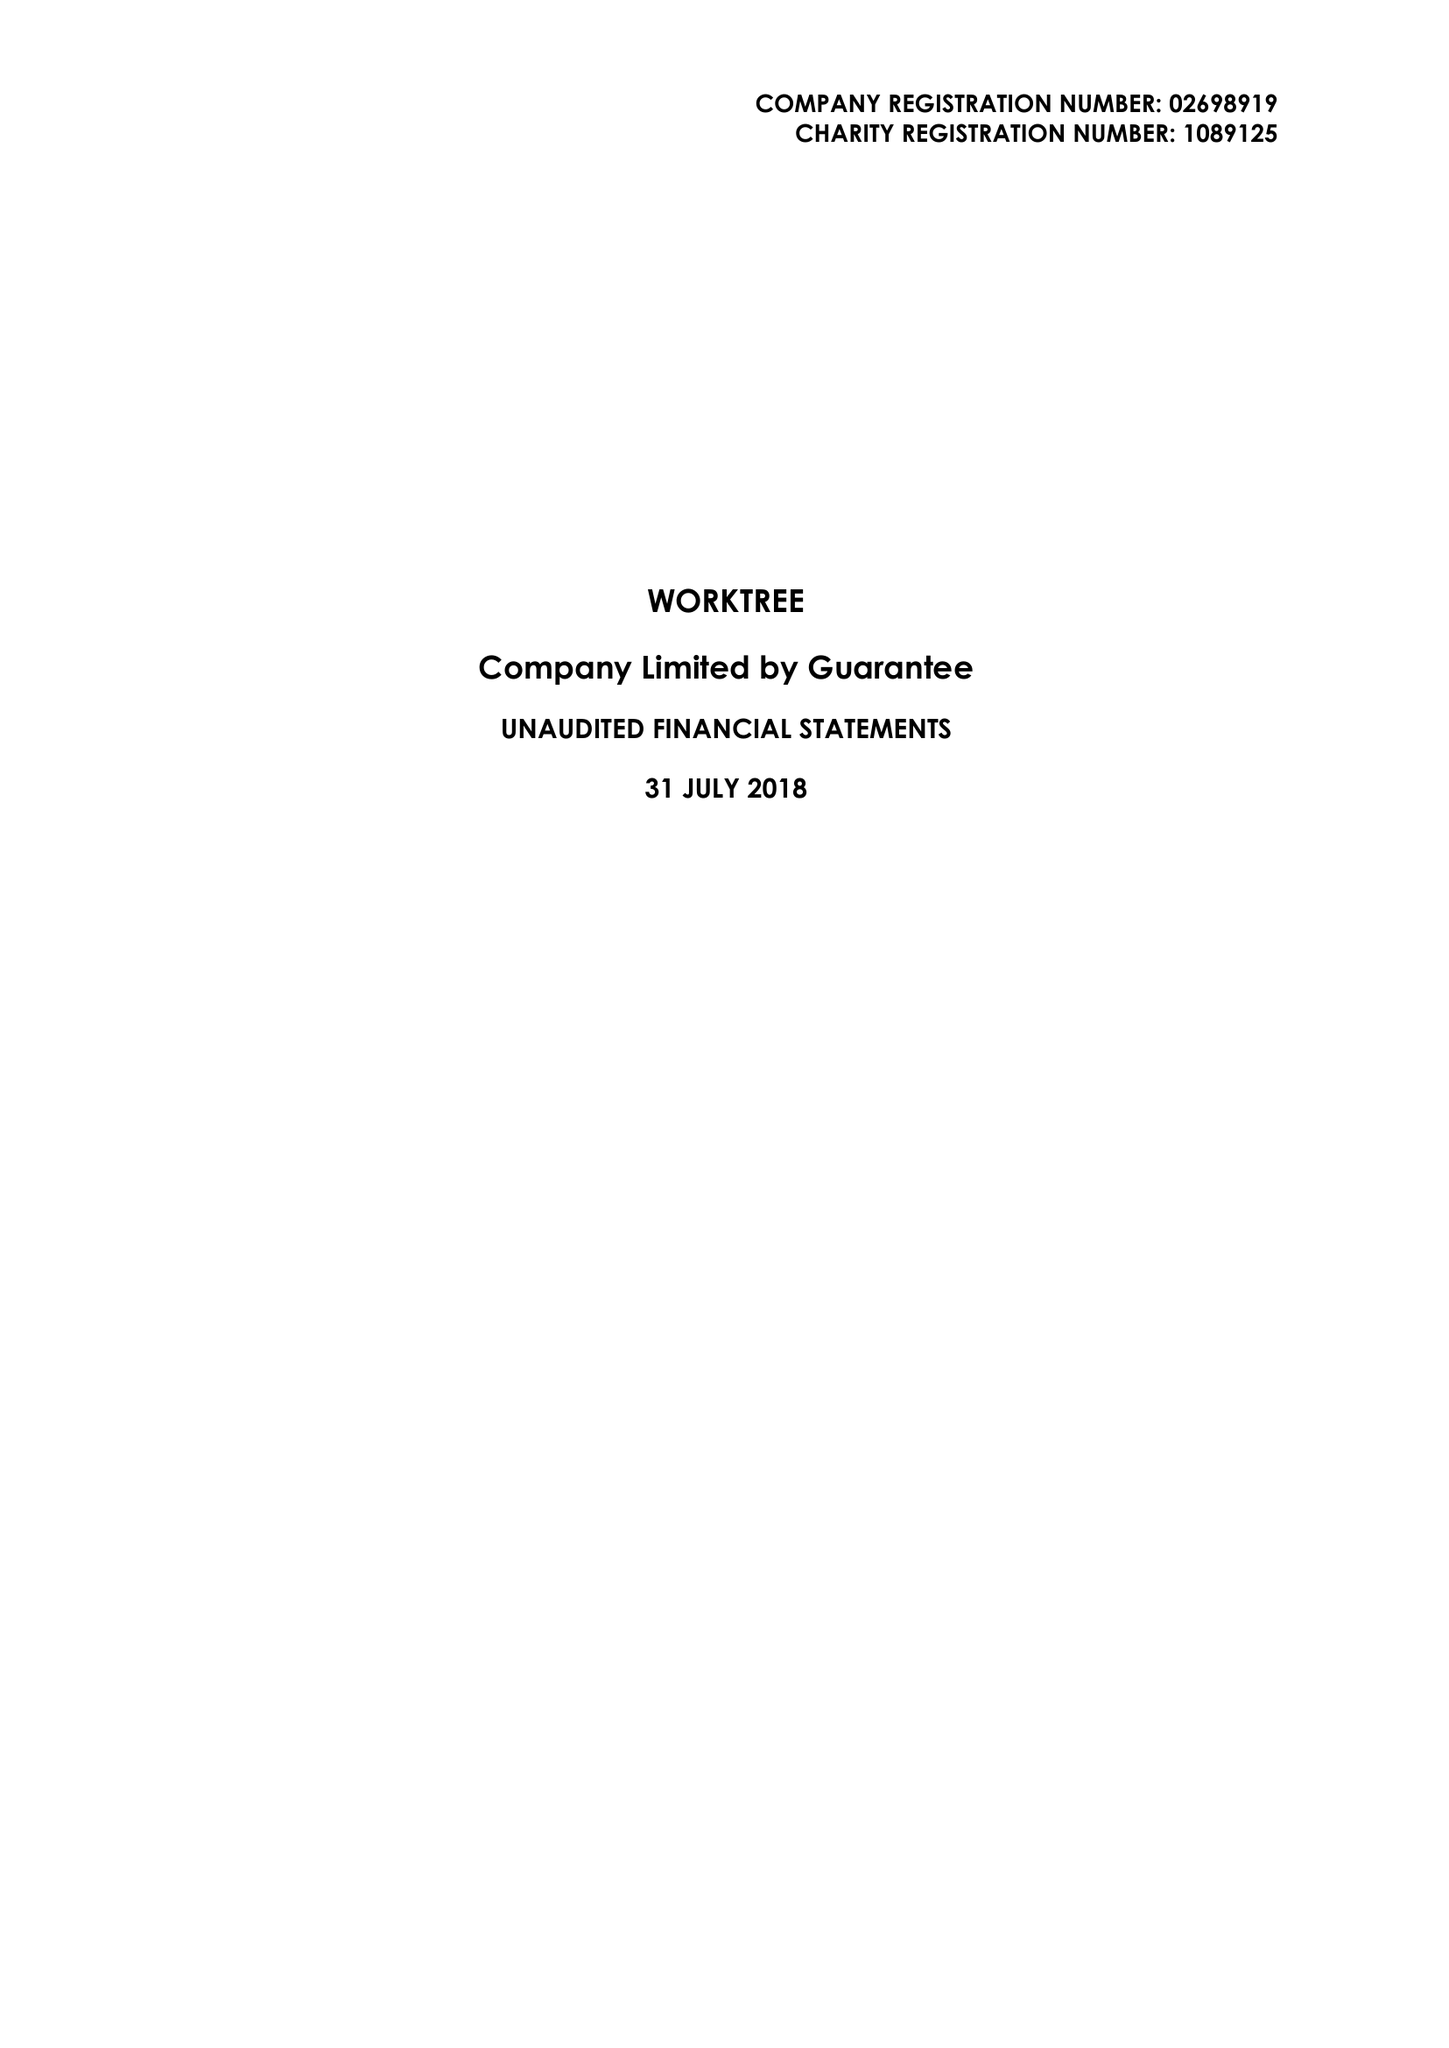What is the value for the address__postcode?
Answer the question using a single word or phrase. MK1 1LG 